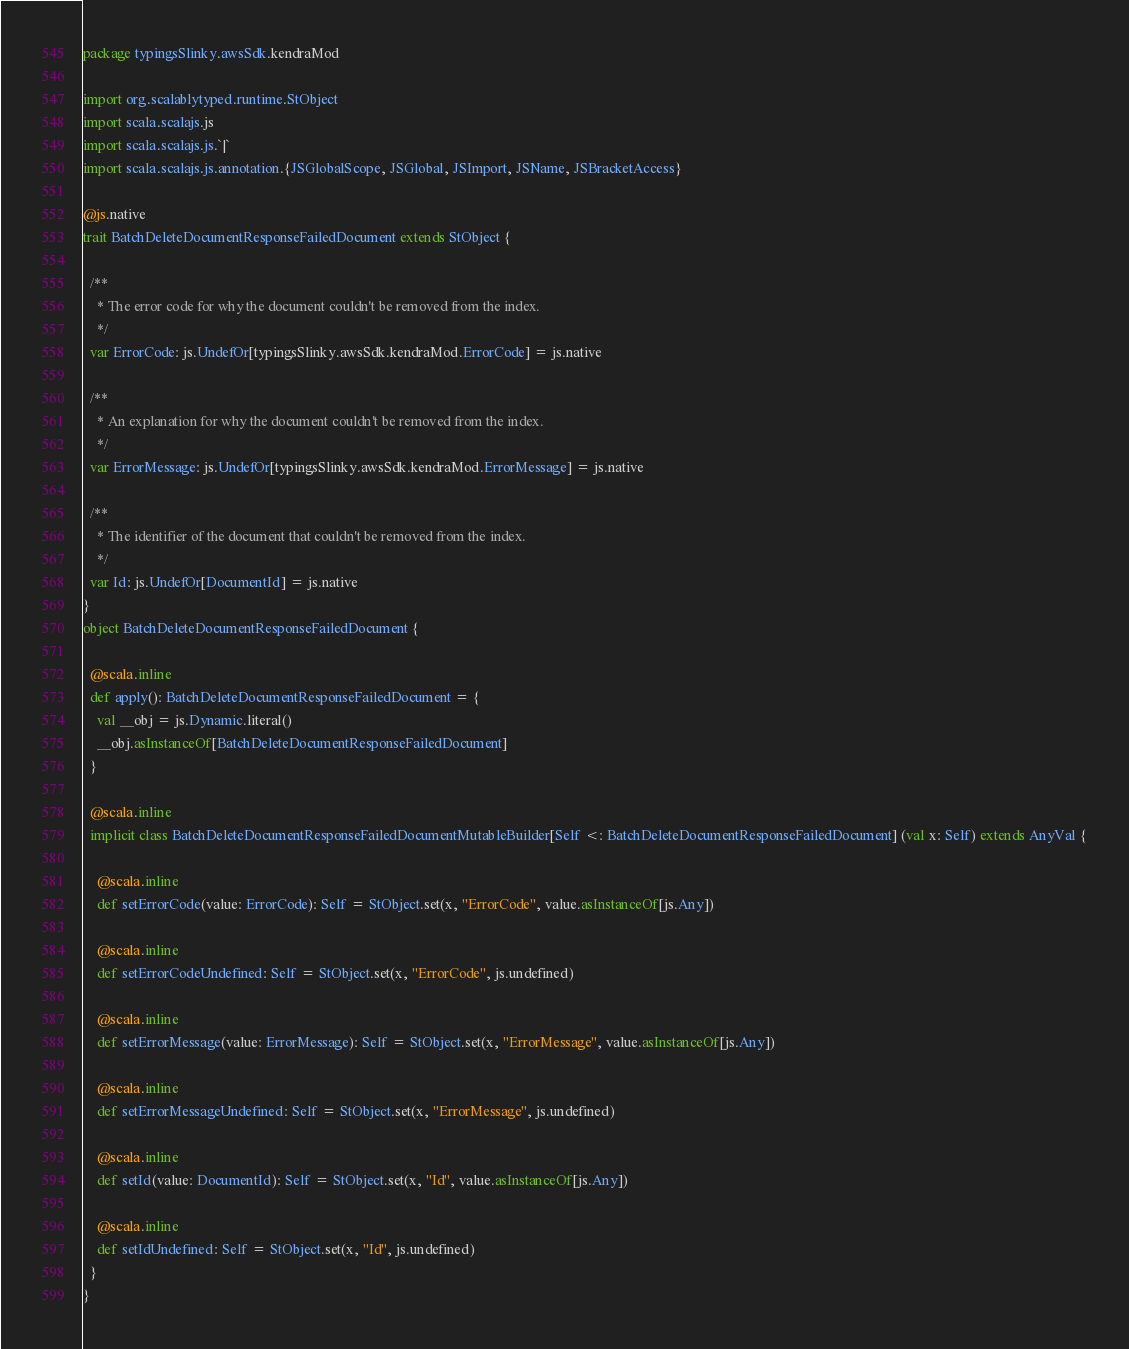Convert code to text. <code><loc_0><loc_0><loc_500><loc_500><_Scala_>package typingsSlinky.awsSdk.kendraMod

import org.scalablytyped.runtime.StObject
import scala.scalajs.js
import scala.scalajs.js.`|`
import scala.scalajs.js.annotation.{JSGlobalScope, JSGlobal, JSImport, JSName, JSBracketAccess}

@js.native
trait BatchDeleteDocumentResponseFailedDocument extends StObject {
  
  /**
    * The error code for why the document couldn't be removed from the index.
    */
  var ErrorCode: js.UndefOr[typingsSlinky.awsSdk.kendraMod.ErrorCode] = js.native
  
  /**
    * An explanation for why the document couldn't be removed from the index.
    */
  var ErrorMessage: js.UndefOr[typingsSlinky.awsSdk.kendraMod.ErrorMessage] = js.native
  
  /**
    * The identifier of the document that couldn't be removed from the index.
    */
  var Id: js.UndefOr[DocumentId] = js.native
}
object BatchDeleteDocumentResponseFailedDocument {
  
  @scala.inline
  def apply(): BatchDeleteDocumentResponseFailedDocument = {
    val __obj = js.Dynamic.literal()
    __obj.asInstanceOf[BatchDeleteDocumentResponseFailedDocument]
  }
  
  @scala.inline
  implicit class BatchDeleteDocumentResponseFailedDocumentMutableBuilder[Self <: BatchDeleteDocumentResponseFailedDocument] (val x: Self) extends AnyVal {
    
    @scala.inline
    def setErrorCode(value: ErrorCode): Self = StObject.set(x, "ErrorCode", value.asInstanceOf[js.Any])
    
    @scala.inline
    def setErrorCodeUndefined: Self = StObject.set(x, "ErrorCode", js.undefined)
    
    @scala.inline
    def setErrorMessage(value: ErrorMessage): Self = StObject.set(x, "ErrorMessage", value.asInstanceOf[js.Any])
    
    @scala.inline
    def setErrorMessageUndefined: Self = StObject.set(x, "ErrorMessage", js.undefined)
    
    @scala.inline
    def setId(value: DocumentId): Self = StObject.set(x, "Id", value.asInstanceOf[js.Any])
    
    @scala.inline
    def setIdUndefined: Self = StObject.set(x, "Id", js.undefined)
  }
}
</code> 